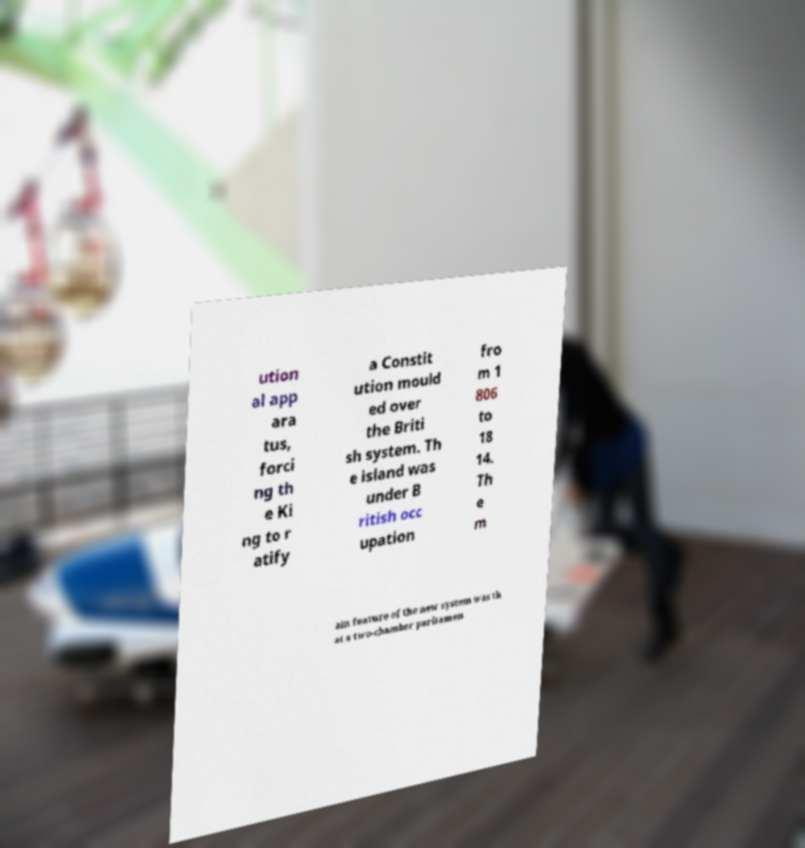I need the written content from this picture converted into text. Can you do that? ution al app ara tus, forci ng th e Ki ng to r atify a Constit ution mould ed over the Briti sh system. Th e island was under B ritish occ upation fro m 1 806 to 18 14. Th e m ain feature of the new system was th at a two-chamber parliamen 